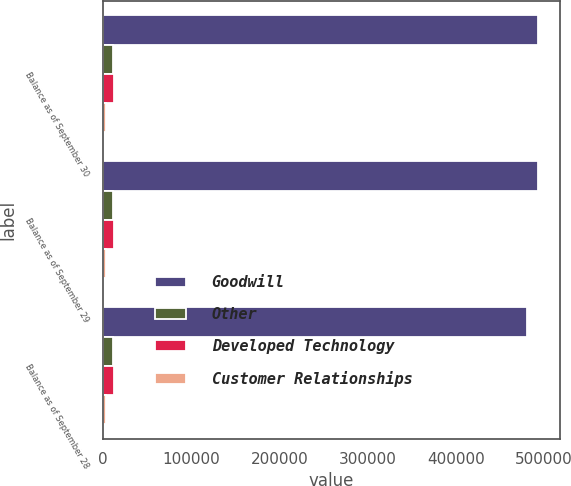Convert chart to OTSL. <chart><loc_0><loc_0><loc_500><loc_500><stacked_bar_chart><ecel><fcel>Balance as of September 30<fcel>Balance as of September 29<fcel>Balance as of September 28<nl><fcel>Goodwill<fcel>493389<fcel>493389<fcel>480890<nl><fcel>Other<fcel>10550<fcel>10550<fcel>10550<nl><fcel>Developed Technology<fcel>12700<fcel>12700<fcel>12700<nl><fcel>Customer Relationships<fcel>3269<fcel>3269<fcel>3269<nl></chart> 